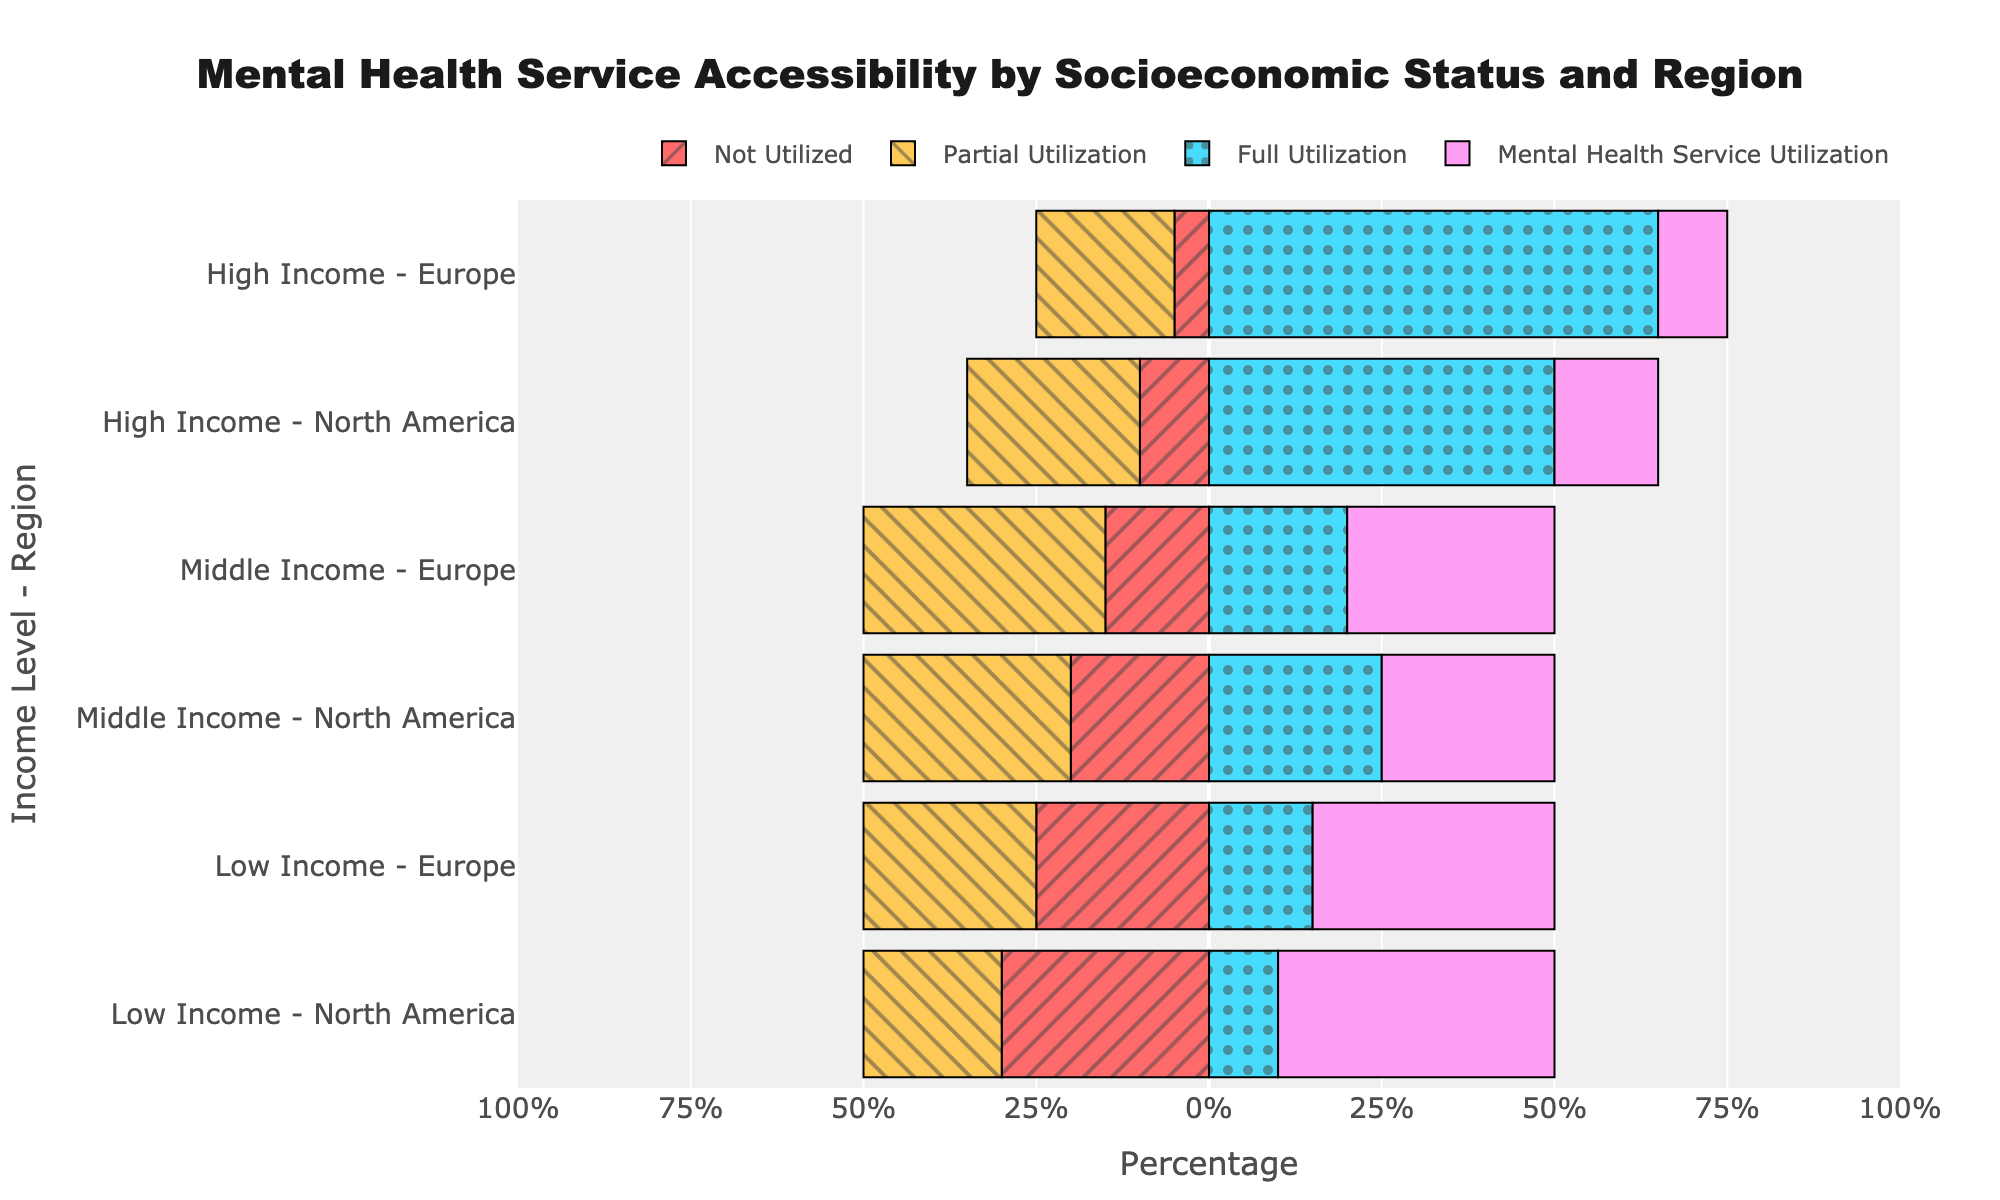What percentage of low-income individuals in North America fully utilize mental health services? Looking at the bar corresponding to "Low Income - North America," the segment for "Full Utilization" shows a length of 10%.
Answer: 10% Which income level in Europe has the highest full utilization of mental health services? Comparing the "Full Utilization" segments for low, middle, and high income in Europe, we see that high income has the longest bar at 65%.
Answer: High Income How does partial utilization in low-income groups compare between North America and Europe? In North America, the partial utilization for low income is -30%. In Europe, it is -25%. Comparing these absolute values, -30% is greater than -25%.
Answer: Higher in North America Which region has the lowest full utilization among middle-income groups? Comparing "Middle Income - North America" with a full utilization of 25% and "Middle Income - Europe" with 20%, Europe has the lowest.
Answer: Europe How much greater is the percentage of full utilization in high-income individuals in North America compared to low-income individuals in North America? Full utilization for high-income in North America is 50%, and for low-income, it is 10%. 50% - 10% = 40%.
Answer: 40% What is the difference in full utilization between middle-income individuals in North America and those in Europe? Full utilization for "Middle Income - North America" is 25%, and for Europe, it’s 20%. The difference is 25% - 20% = 5%.
Answer: 5% 